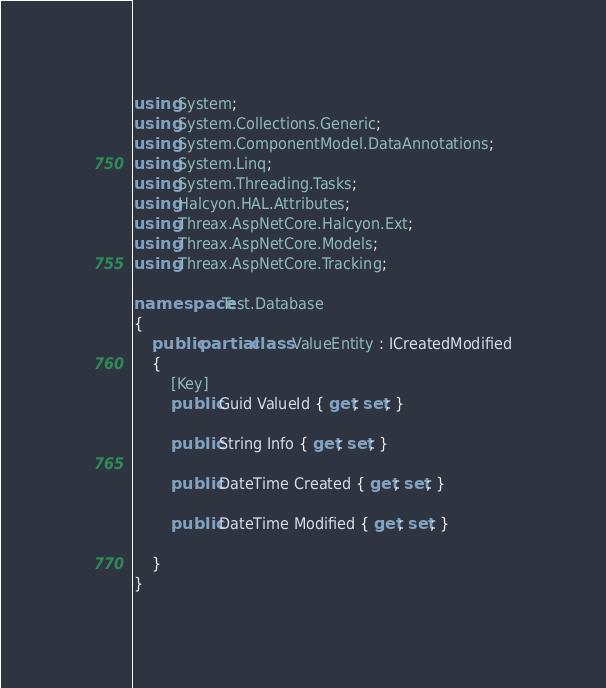Convert code to text. <code><loc_0><loc_0><loc_500><loc_500><_C#_>using System;
using System.Collections.Generic;
using System.ComponentModel.DataAnnotations;
using System.Linq;
using System.Threading.Tasks;
using Halcyon.HAL.Attributes;
using Threax.AspNetCore.Halcyon.Ext;
using Threax.AspNetCore.Models;
using Threax.AspNetCore.Tracking;

namespace Test.Database 
{
    public partial class ValueEntity : ICreatedModified
    {
        [Key]
        public Guid ValueId { get; set; }

        public String Info { get; set; }

        public DateTime Created { get; set; }

        public DateTime Modified { get; set; }

    }
}
</code> 